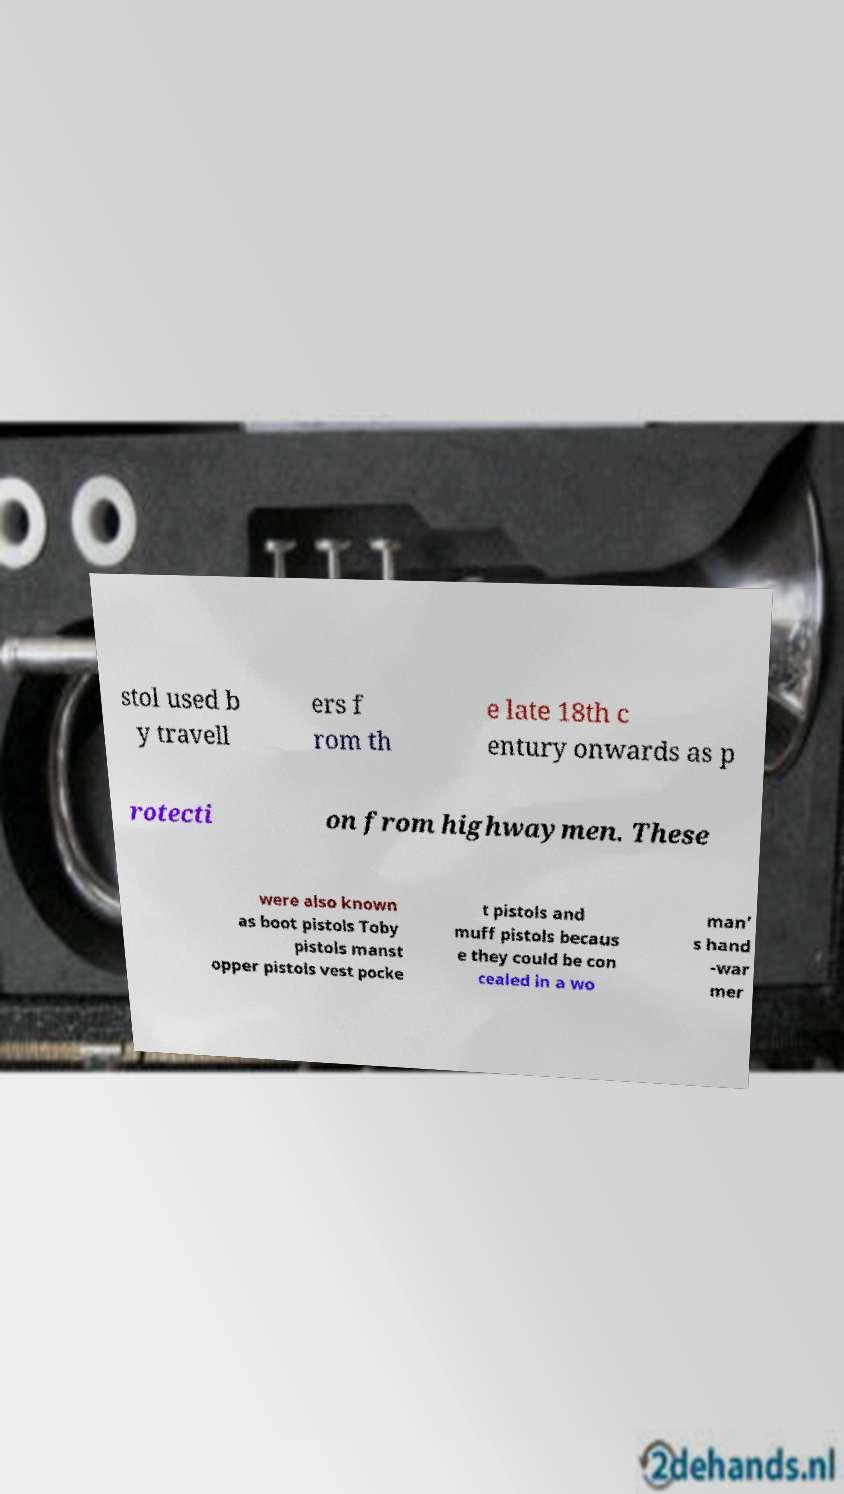There's text embedded in this image that I need extracted. Can you transcribe it verbatim? stol used b y travell ers f rom th e late 18th c entury onwards as p rotecti on from highwaymen. These were also known as boot pistols Toby pistols manst opper pistols vest pocke t pistols and muff pistols becaus e they could be con cealed in a wo man’ s hand -war mer 